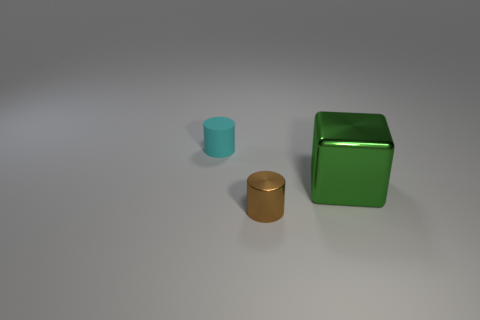What materials do the objects in the image seem to be made of? The objects in the image include a cylinder that appears to be made of metal, a shiny cube that resembles plastic or polished metal, and a smaller cylinder that looks like it could be made of a matte material, possibly plastic. What time of day does the lighting in the image suggest? The lighting in the image indicates an indoor setting with artificial light sources, possibly situated above the objects, casting soft shadows on the surface beneath them. 